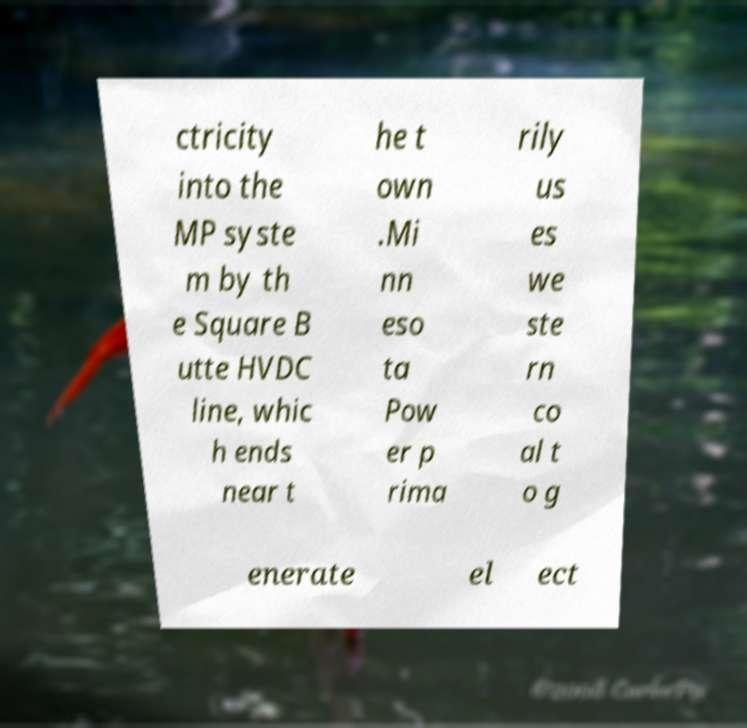I need the written content from this picture converted into text. Can you do that? ctricity into the MP syste m by th e Square B utte HVDC line, whic h ends near t he t own .Mi nn eso ta Pow er p rima rily us es we ste rn co al t o g enerate el ect 